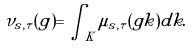<formula> <loc_0><loc_0><loc_500><loc_500>\nu _ { s , \tau } ( g ) = \int _ { K } \mu _ { s , \tau } ( g k ) d k .</formula> 